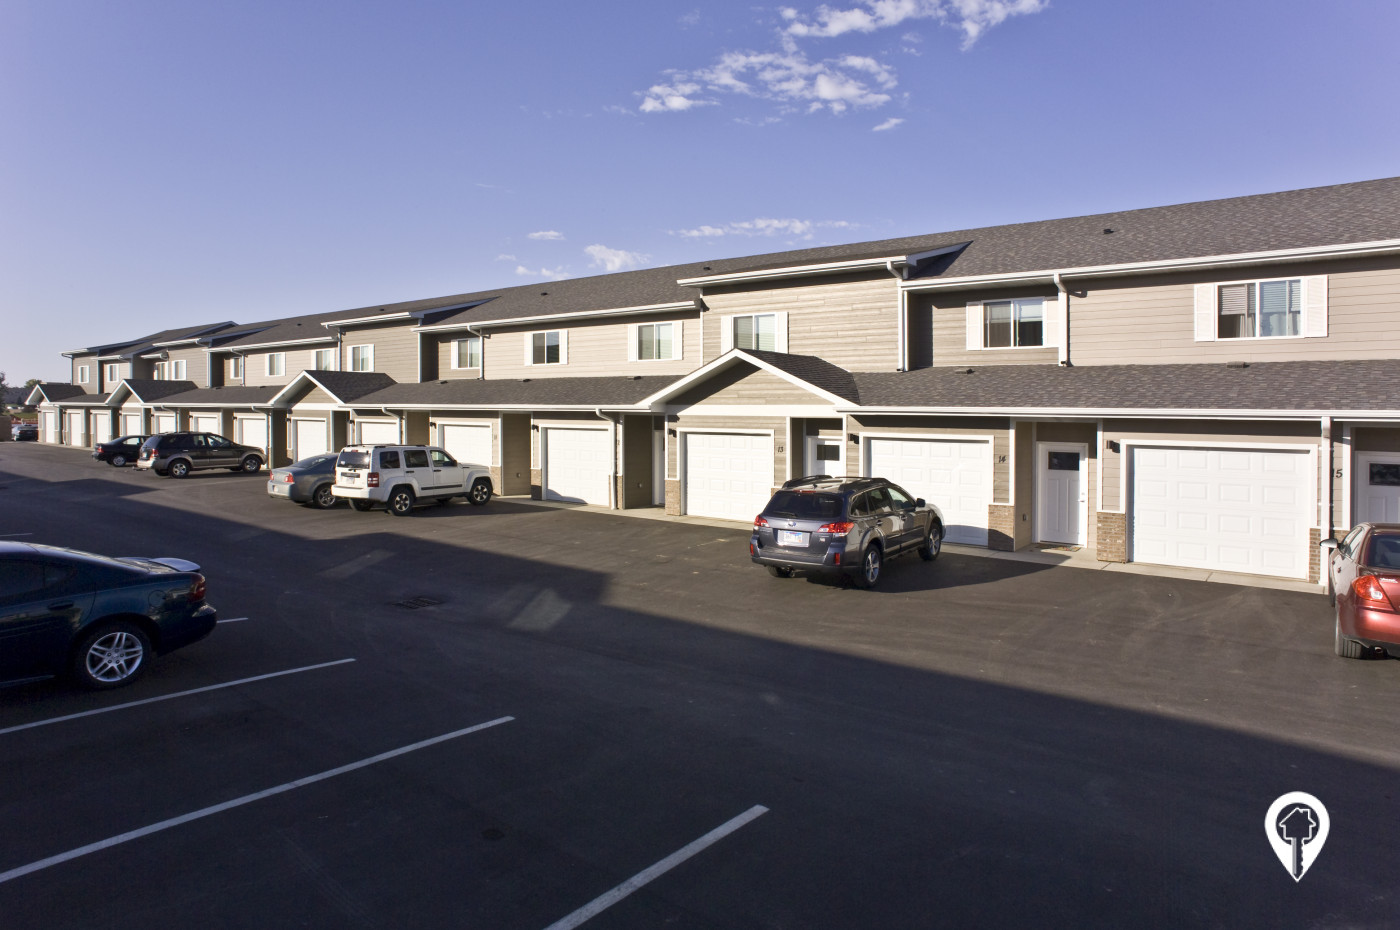Can the position of the sun be inferred from the shadows, and what time of day might it indicate? Yes, the position of the sun is indicated by the shadow directions in the image. The shadows cast by the vehicles and townhouses fall towards the right, suggesting the sun is to the left of the scene. This positioning, along with the relatively long shadows, indicates that the sun is somewhat lower in the sky, typical of morning hours. If we assume the townhouses are located in the Northern Hemisphere, the rightward falling shadows also support this morning time theory, as the sun would be towards the southeast. This analysis can help in planning events or activities knowing when certain areas will be sunlit or shaded during various parts of the day. 